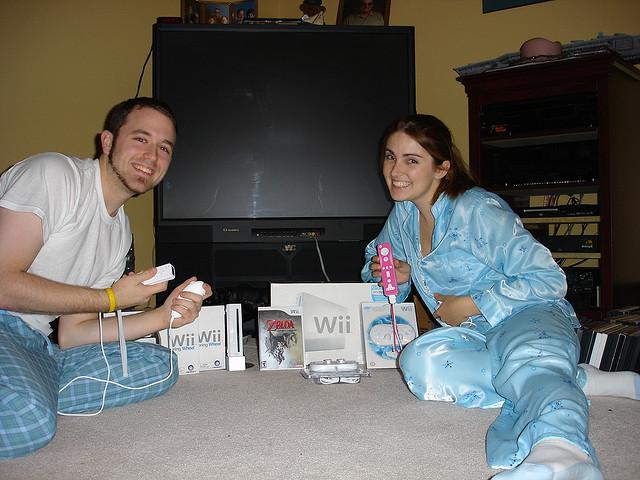Are they happy?
Quick response, please. Yes. What video game system are they playing?
Keep it brief. Wii. Are they in their pajamas?
Short answer required. Yes. 